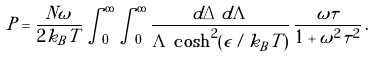Convert formula to latex. <formula><loc_0><loc_0><loc_500><loc_500>P = \frac { N \omega } { 2 k _ { B } T } \int _ { 0 } ^ { \infty } \int _ { 0 } ^ { \infty } \frac { d \Delta \, d \Lambda } { \Lambda \, \cosh ^ { 2 } ( \epsilon / k _ { B } T ) } \, \frac { \omega \tau } { 1 + \omega ^ { 2 } \tau ^ { 2 } } \, .</formula> 